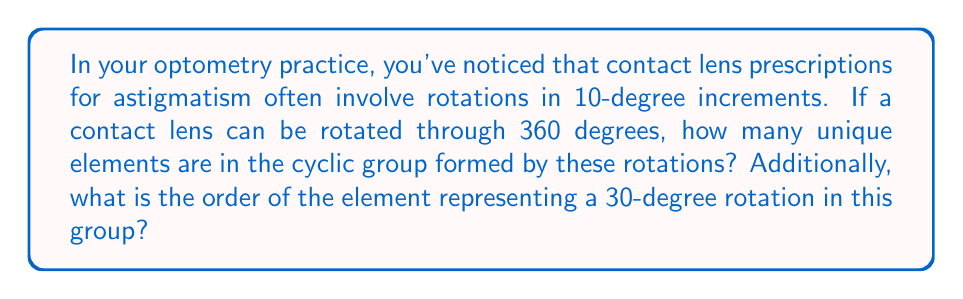What is the answer to this math problem? To solve this problem, we need to understand the concept of cyclic groups and how they apply to rotations:

1) First, let's consider the rotations possible:
   The lens can be rotated in 10-degree increments, and a full rotation is 360 degrees.

2) To find the number of unique elements in the group:
   $$\text{Number of elements} = \frac{360^\circ}{10^\circ} = 36$$

   This means there are 36 unique positions the lens can be in.

3) The cyclic group formed by these rotations can be represented as:
   $$C_{36} = \{0^\circ, 10^\circ, 20^\circ, ..., 350^\circ\}$$
   where $0^\circ$ represents the identity element.

4) To find the order of the element representing a 30-degree rotation:
   - Let's call this element $a$.
   - We need to find the smallest positive integer $n$ such that $a^n = e$ (the identity element).
   - In other words, we need to find how many 30-degree rotations bring us back to the starting position.
   
   $$30^\circ \cdot n \equiv 0^\circ \pmod{360^\circ}$$
   $$n = \frac{360^\circ}{30^\circ} = 12$$

Therefore, the order of the 30-degree rotation element is 12.
Answer: The cyclic group formed by the rotations has 36 unique elements. The order of the element representing a 30-degree rotation is 12. 